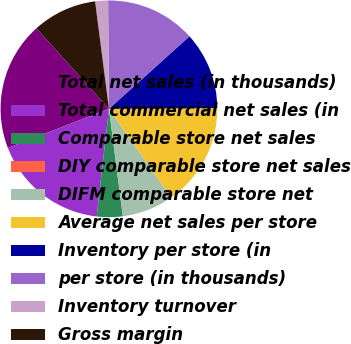Convert chart to OTSL. <chart><loc_0><loc_0><loc_500><loc_500><pie_chart><fcel>Total net sales (in thousands)<fcel>Total commercial net sales (in<fcel>Comparable store net sales<fcel>DIY comparable store net sales<fcel>DIFM comparable store net<fcel>Average net sales per store<fcel>Inventory per store (in<fcel>per store (in thousands)<fcel>Inventory turnover<fcel>Gross margin<nl><fcel>19.23%<fcel>17.31%<fcel>3.85%<fcel>0.0%<fcel>7.69%<fcel>15.38%<fcel>11.54%<fcel>13.46%<fcel>1.92%<fcel>9.62%<nl></chart> 